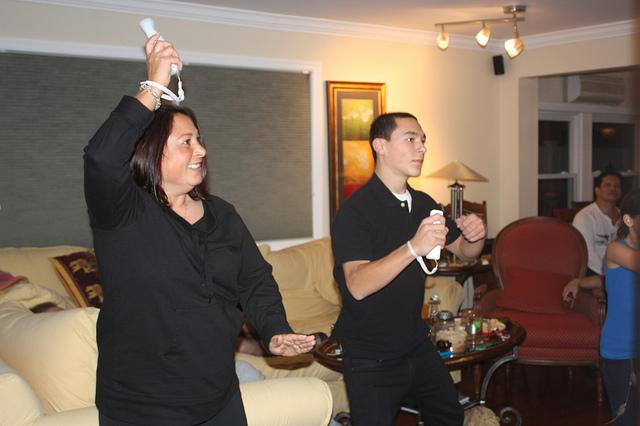The relationship between these people is most likely what?

Choices:
A) enemies
B) coworkers
C) strangers
D) family family 